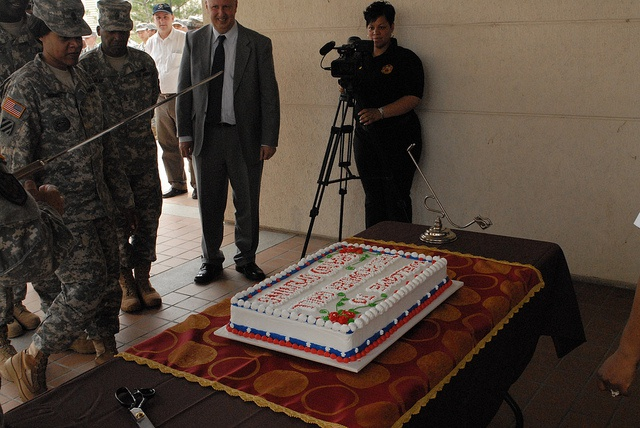Describe the objects in this image and their specific colors. I can see dining table in black, maroon, and olive tones, people in black, gray, and maroon tones, people in black, gray, maroon, and darkgray tones, cake in black, darkgray, and gray tones, and people in black, gray, and maroon tones in this image. 